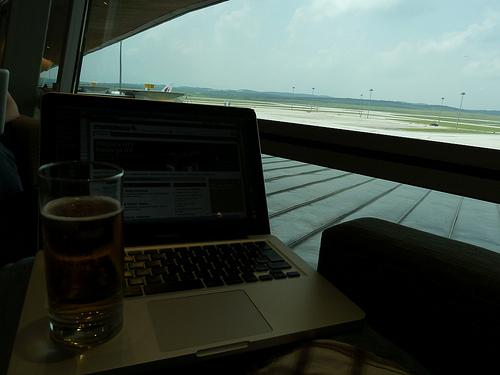Question: how many glasses are there?
Choices:
A. Two.
B. Zero.
C. Three.
D. One.
Answer with the letter. Answer: D Question: why is the laptop open?
Choices:
A. On the task manager.
B. On the Chat screen.
C. On the internet.
D. On restart.
Answer with the letter. Answer: C Question: what is sitting on the laptop?
Choices:
A. Glass of beer.
B. Cat.
C. Mouse.
D. Eyeglasses.
Answer with the letter. Answer: A Question: what can be seen out the window?
Choices:
A. Ocean.
B. Airport.
C. Bridge.
D. Fire truck.
Answer with the letter. Answer: B 